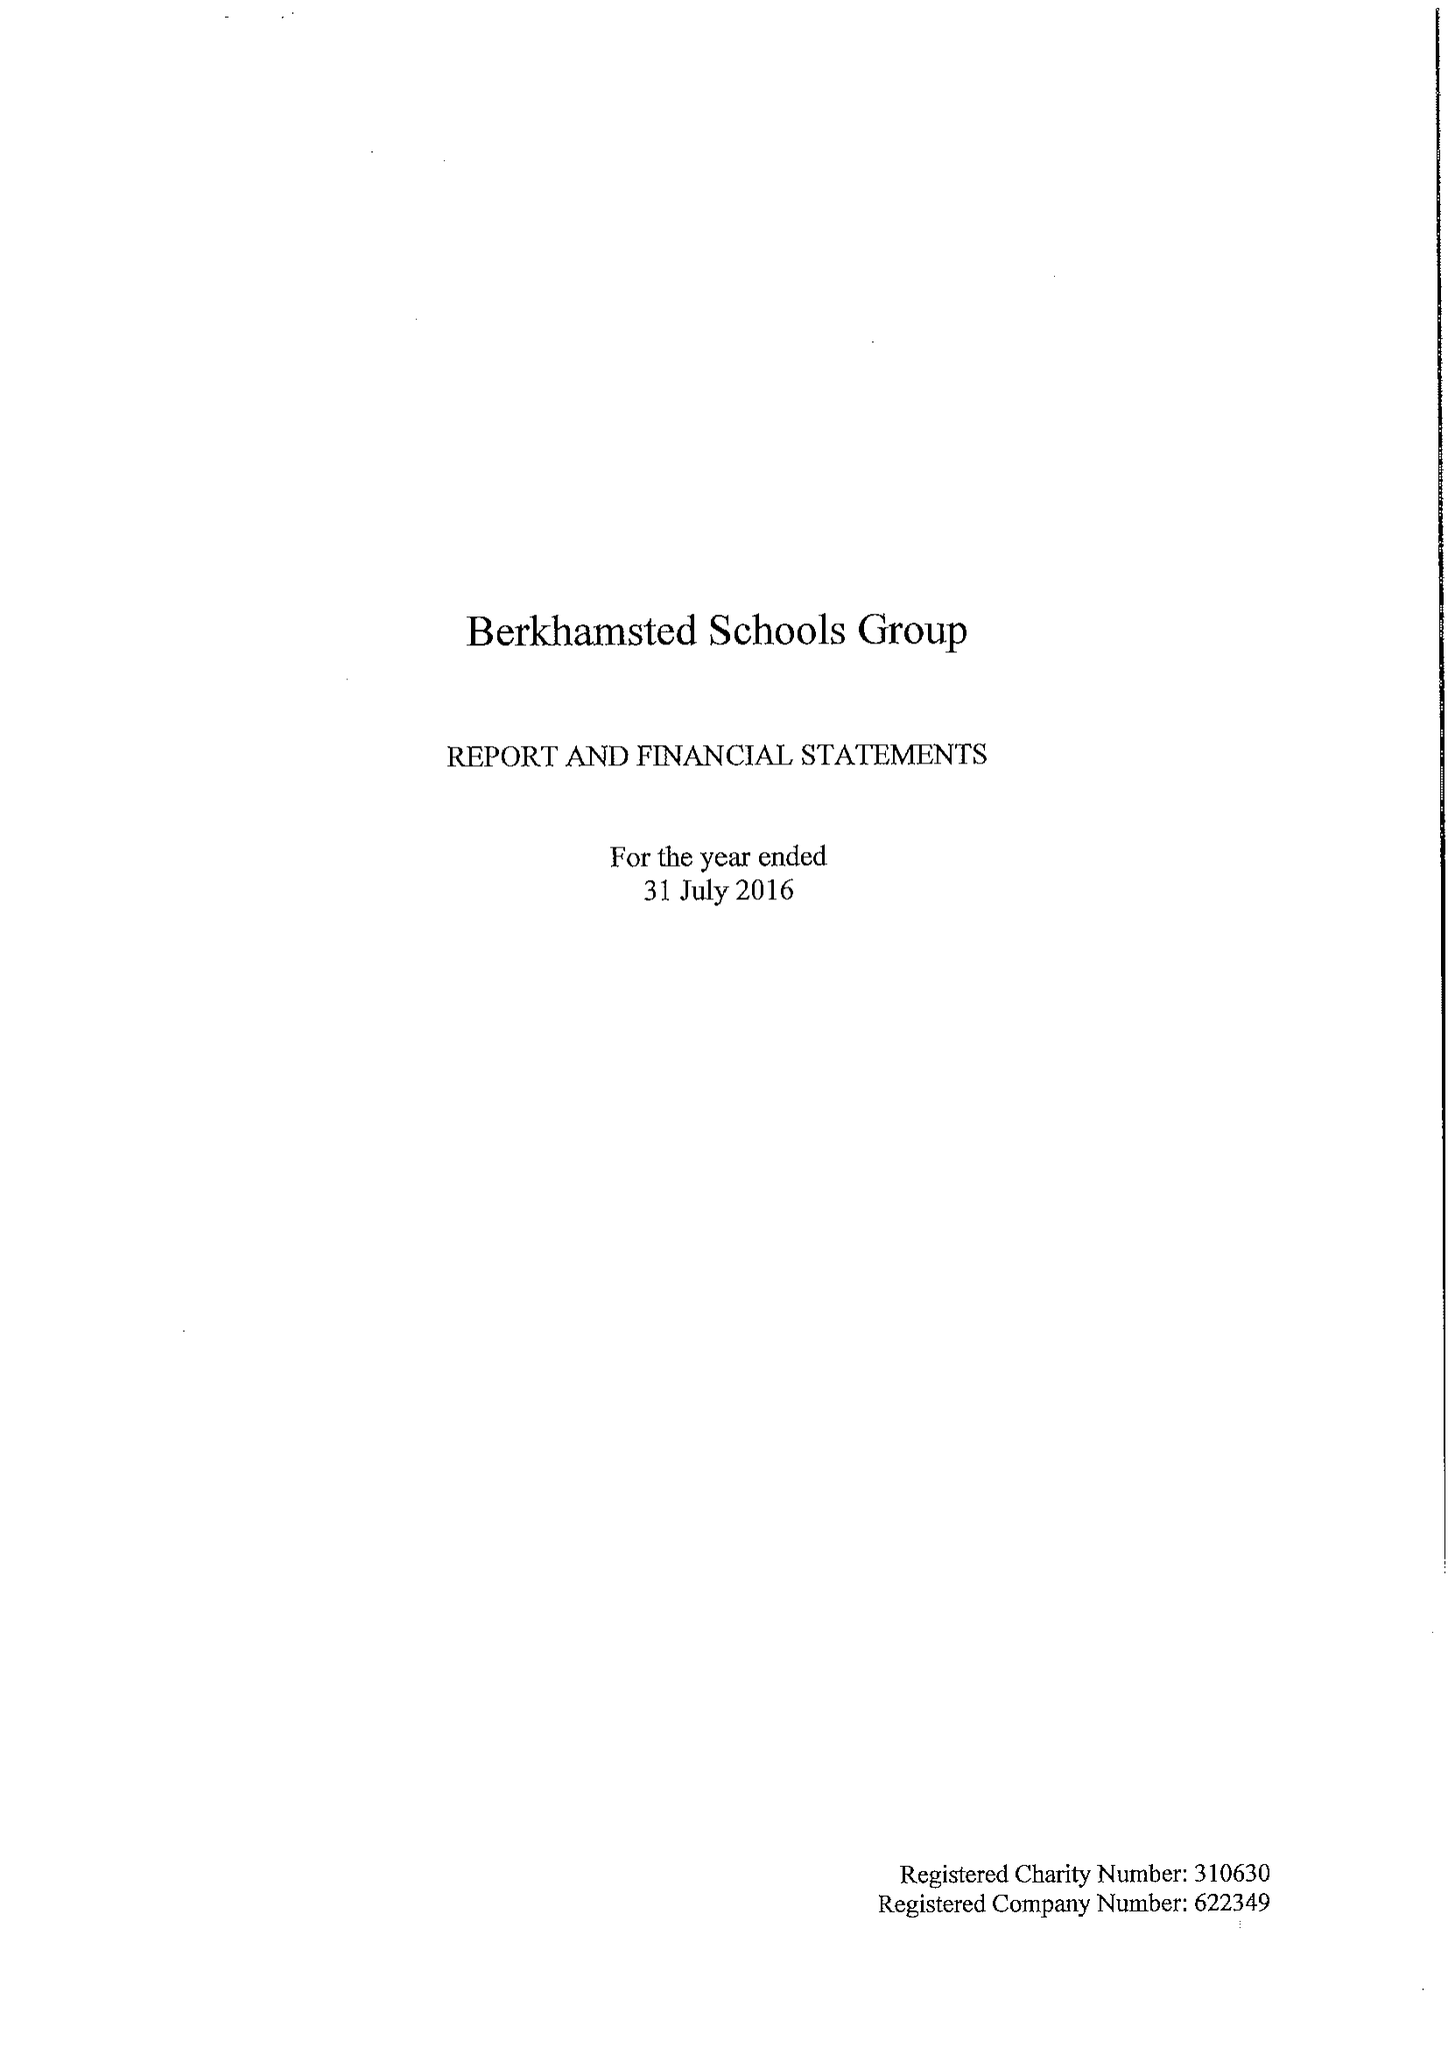What is the value for the report_date?
Answer the question using a single word or phrase. 2016-07-31 